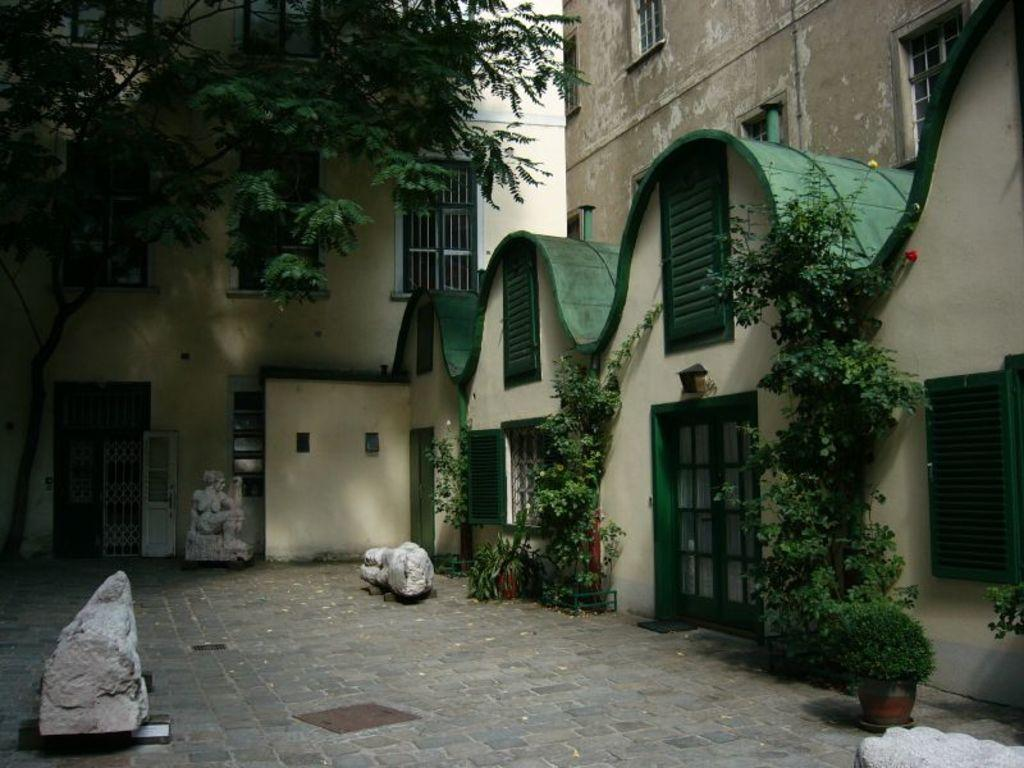What type of objects can be seen in the image? There are statues, plants, buildings, windows, and doors in the image. Can you describe the architectural elements in the image? The image features buildings with windows and doors. What type of natural elements are present in the image? There are plants in the image. What type of clouds can be seen in the image? There are no clouds present in the image. What news is being reported by the statues in the image? The statues in the image are not reporting any news; they are stationary objects. 